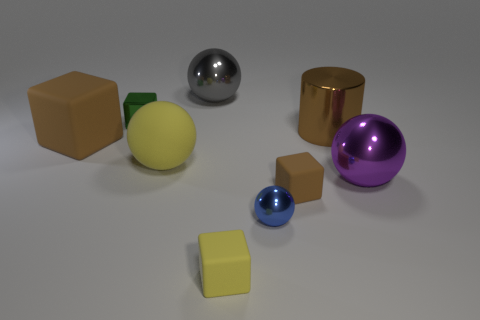What material is the big object that is to the left of the big purple sphere and on the right side of the blue metallic sphere? metal 